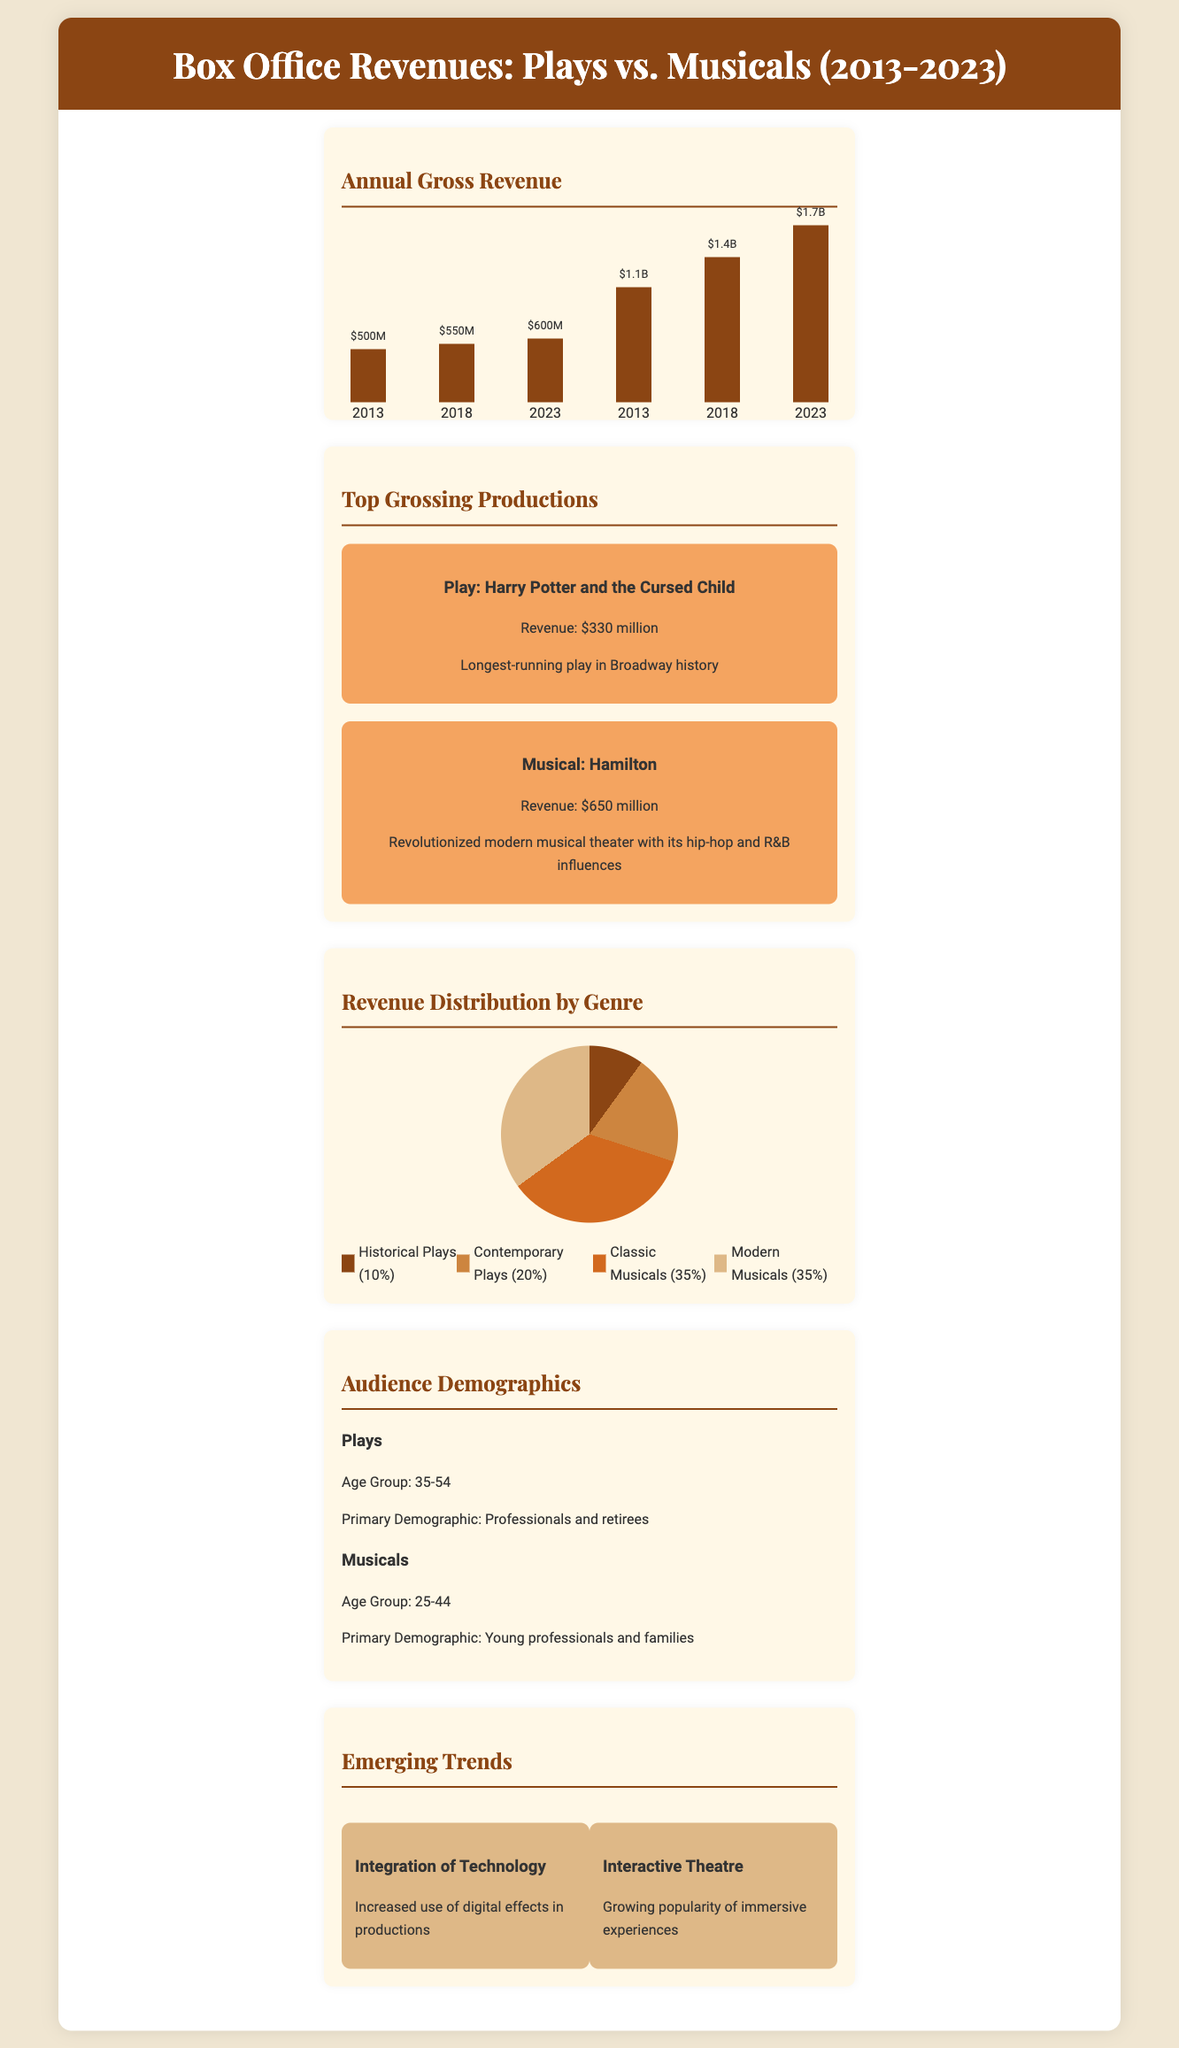What was the revenue for musicals in 2023? The revenue for musicals in 2023 is listed in the bar chart as $1.7 billion.
Answer: $1.7B What age group primarily attends plays? The demographic information shows that professionals and retirees, aged 35-54, primarily attend plays.
Answer: 35-54 Which production had the highest revenue? The top-grossing section states "Hamilton" is the musical with the highest revenue at $650 million.
Answer: Hamilton What percentage of revenue comes from classic musicals? The pie chart indicates that classic musicals account for 35% of revenue distribution.
Answer: 35% What significant trend involves digital effects? The document mentions "Integration of Technology" as a trend involving digital effects in productions.
Answer: Integration of Technology What is the revenue of "Harry Potter and the Cursed Child"? The top-grossing section states that "Harry Potter and the Cursed Child" has a revenue of $330 million.
Answer: $330 million Which category does not exceed 20% in revenue distribution? The revenue distribution shows that Historical Plays account for only 10%, which does not exceed 20%.
Answer: Historical Plays What has been a growing trend in theatre? The document notes "Interactive Theatre" as a growing trend, emphasizing immersive experiences.
Answer: Interactive Theatre 